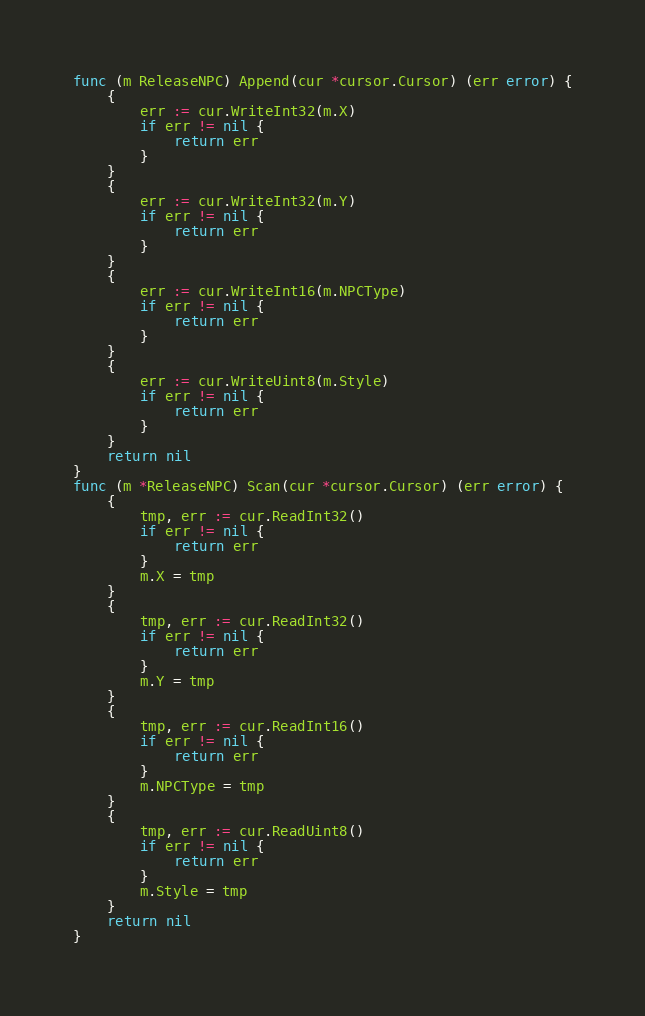Convert code to text. <code><loc_0><loc_0><loc_500><loc_500><_Go_>func (m ReleaseNPC) Append(cur *cursor.Cursor) (err error) {
	{
		err := cur.WriteInt32(m.X)
		if err != nil {
			return err
		}
	}
	{
		err := cur.WriteInt32(m.Y)
		if err != nil {
			return err
		}
	}
	{
		err := cur.WriteInt16(m.NPCType)
		if err != nil {
			return err
		}
	}
	{
		err := cur.WriteUint8(m.Style)
		if err != nil {
			return err
		}
	}
	return nil
}
func (m *ReleaseNPC) Scan(cur *cursor.Cursor) (err error) {
	{
		tmp, err := cur.ReadInt32()
		if err != nil {
			return err
		}
		m.X = tmp
	}
	{
		tmp, err := cur.ReadInt32()
		if err != nil {
			return err
		}
		m.Y = tmp
	}
	{
		tmp, err := cur.ReadInt16()
		if err != nil {
			return err
		}
		m.NPCType = tmp
	}
	{
		tmp, err := cur.ReadUint8()
		if err != nil {
			return err
		}
		m.Style = tmp
	}
	return nil
}
</code> 